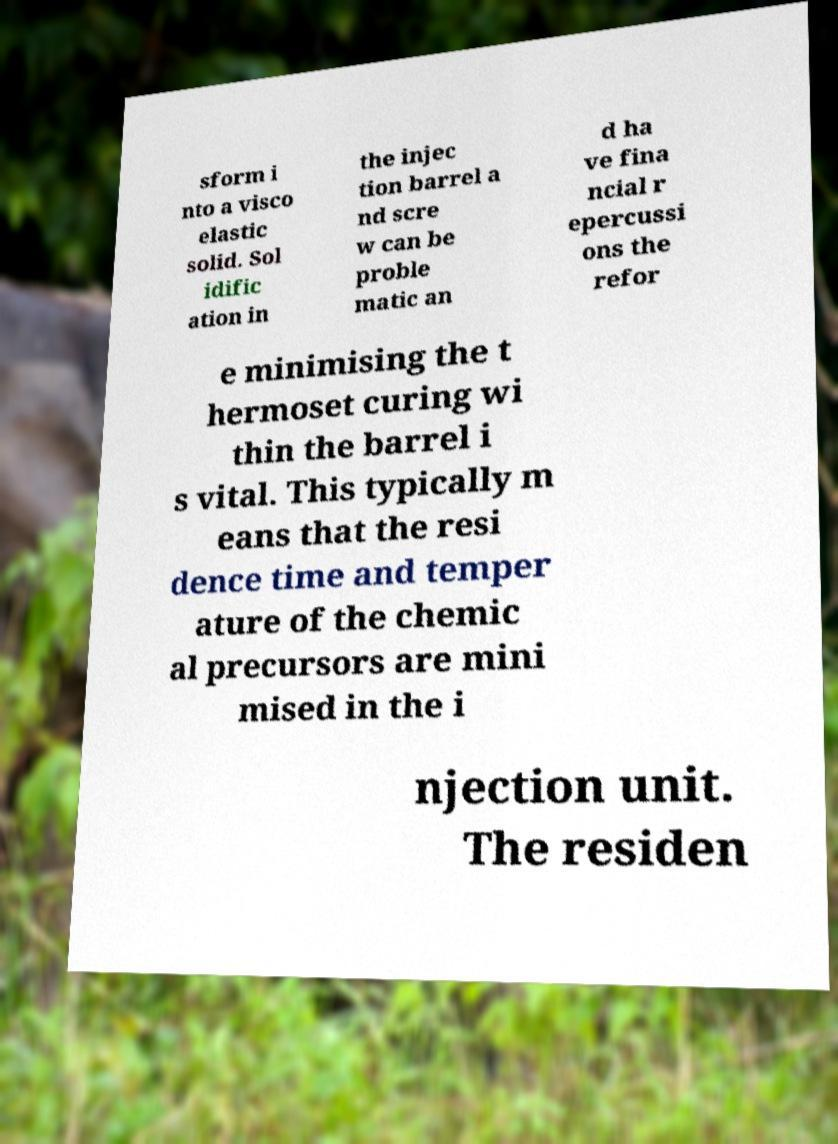For documentation purposes, I need the text within this image transcribed. Could you provide that? sform i nto a visco elastic solid. Sol idific ation in the injec tion barrel a nd scre w can be proble matic an d ha ve fina ncial r epercussi ons the refor e minimising the t hermoset curing wi thin the barrel i s vital. This typically m eans that the resi dence time and temper ature of the chemic al precursors are mini mised in the i njection unit. The residen 